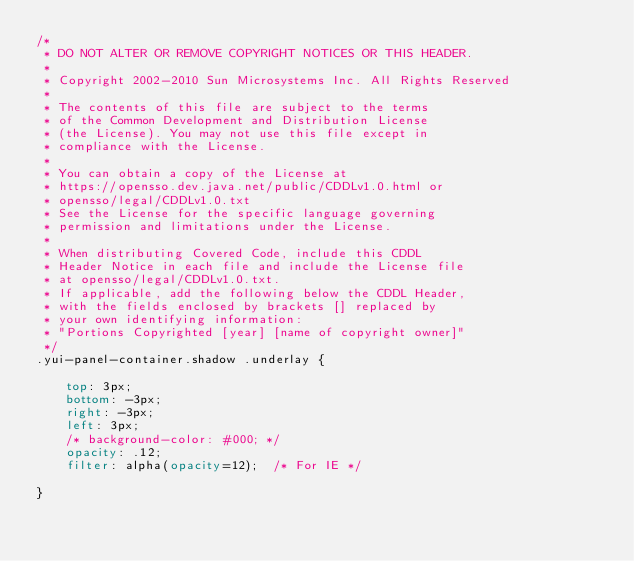Convert code to text. <code><loc_0><loc_0><loc_500><loc_500><_CSS_>/*
 * DO NOT ALTER OR REMOVE COPYRIGHT NOTICES OR THIS HEADER.
 *
 * Copyright 2002-2010 Sun Microsystems Inc. All Rights Reserved
 *
 * The contents of this file are subject to the terms
 * of the Common Development and Distribution License
 * (the License). You may not use this file except in
 * compliance with the License.
 *
 * You can obtain a copy of the License at
 * https://opensso.dev.java.net/public/CDDLv1.0.html or
 * opensso/legal/CDDLv1.0.txt
 * See the License for the specific language governing
 * permission and limitations under the License.
 *
 * When distributing Covered Code, include this CDDL
 * Header Notice in each file and include the License file
 * at opensso/legal/CDDLv1.0.txt.
 * If applicable, add the following below the CDDL Header,
 * with the fields enclosed by brackets [] replaced by
 * your own identifying information:
 * "Portions Copyrighted [year] [name of copyright owner]"
 */
.yui-panel-container.shadow .underlay {

    top: 3px;
    bottom: -3px;
    right: -3px;
    left: 3px;
    /* background-color: #000; */
    opacity: .12;
    filter: alpha(opacity=12);  /* For IE */

}</code> 